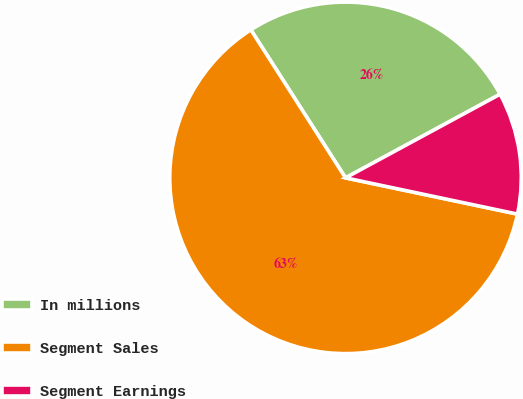Convert chart to OTSL. <chart><loc_0><loc_0><loc_500><loc_500><pie_chart><fcel>In millions<fcel>Segment Sales<fcel>Segment Earnings<nl><fcel>26.16%<fcel>62.64%<fcel>11.2%<nl></chart> 